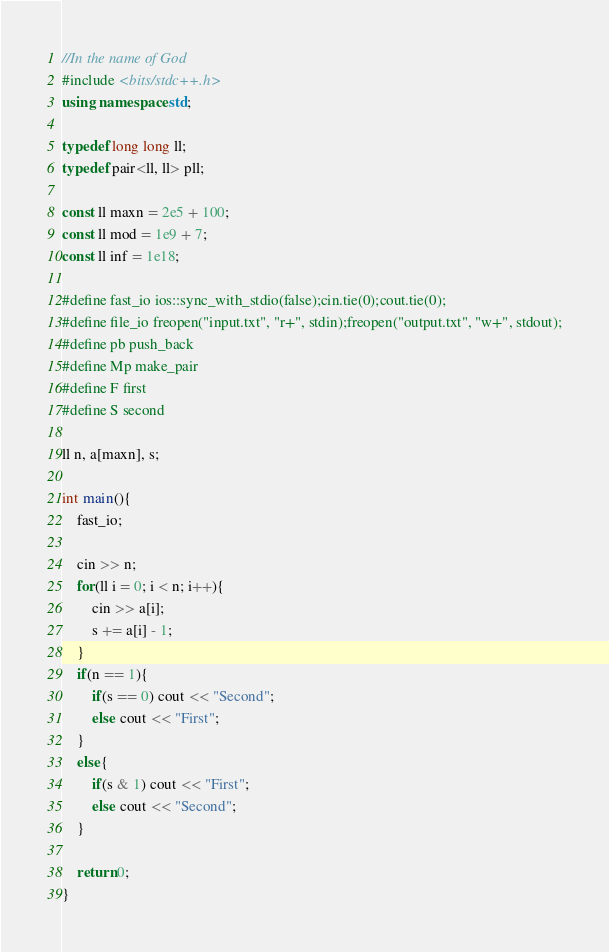Convert code to text. <code><loc_0><loc_0><loc_500><loc_500><_C++_>//In the name of God
#include <bits/stdc++.h>
using namespace std;

typedef long long ll;
typedef pair<ll, ll> pll;

const ll maxn = 2e5 + 100;
const ll mod = 1e9 + 7;
const ll inf = 1e18;

#define fast_io ios::sync_with_stdio(false);cin.tie(0);cout.tie(0);
#define file_io freopen("input.txt", "r+", stdin);freopen("output.txt", "w+", stdout);
#define pb push_back
#define Mp make_pair
#define F first
#define S second

ll n, a[maxn], s;

int main(){
    fast_io;

    cin >> n;
    for(ll i = 0; i < n; i++){
        cin >> a[i];
        s += a[i] - 1;
    }
    if(n == 1){
        if(s == 0) cout << "Second";
        else cout << "First";
    }
    else{
        if(s & 1) cout << "First";
        else cout << "Second";
    }

    return 0;
}</code> 